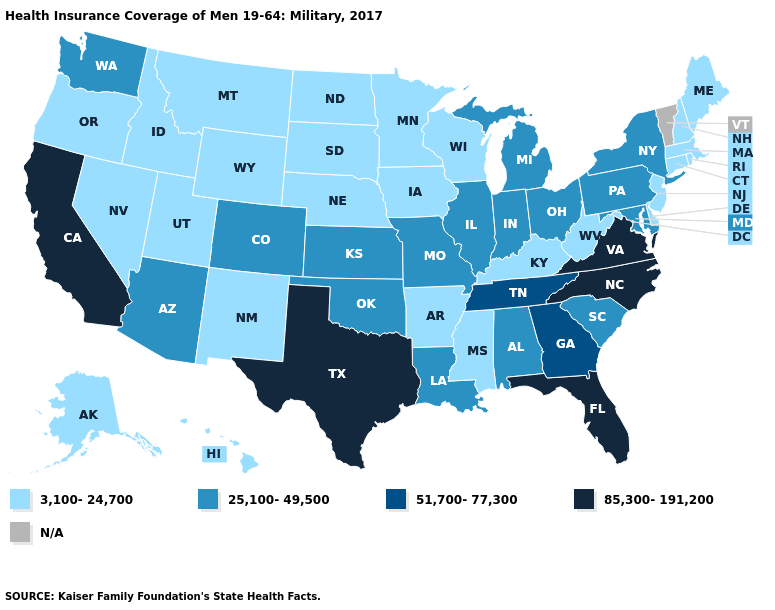Which states have the lowest value in the USA?
Write a very short answer. Alaska, Arkansas, Connecticut, Delaware, Hawaii, Idaho, Iowa, Kentucky, Maine, Massachusetts, Minnesota, Mississippi, Montana, Nebraska, Nevada, New Hampshire, New Jersey, New Mexico, North Dakota, Oregon, Rhode Island, South Dakota, Utah, West Virginia, Wisconsin, Wyoming. Does Missouri have the lowest value in the USA?
Short answer required. No. Name the states that have a value in the range 85,300-191,200?
Be succinct. California, Florida, North Carolina, Texas, Virginia. What is the value of Florida?
Quick response, please. 85,300-191,200. What is the value of Wisconsin?
Quick response, please. 3,100-24,700. What is the value of Washington?
Write a very short answer. 25,100-49,500. What is the lowest value in states that border Minnesota?
Concise answer only. 3,100-24,700. Name the states that have a value in the range 85,300-191,200?
Short answer required. California, Florida, North Carolina, Texas, Virginia. Which states hav the highest value in the West?
Write a very short answer. California. Among the states that border Maine , which have the highest value?
Short answer required. New Hampshire. Name the states that have a value in the range 51,700-77,300?
Be succinct. Georgia, Tennessee. Name the states that have a value in the range 25,100-49,500?
Short answer required. Alabama, Arizona, Colorado, Illinois, Indiana, Kansas, Louisiana, Maryland, Michigan, Missouri, New York, Ohio, Oklahoma, Pennsylvania, South Carolina, Washington. Does the map have missing data?
Keep it brief. Yes. 